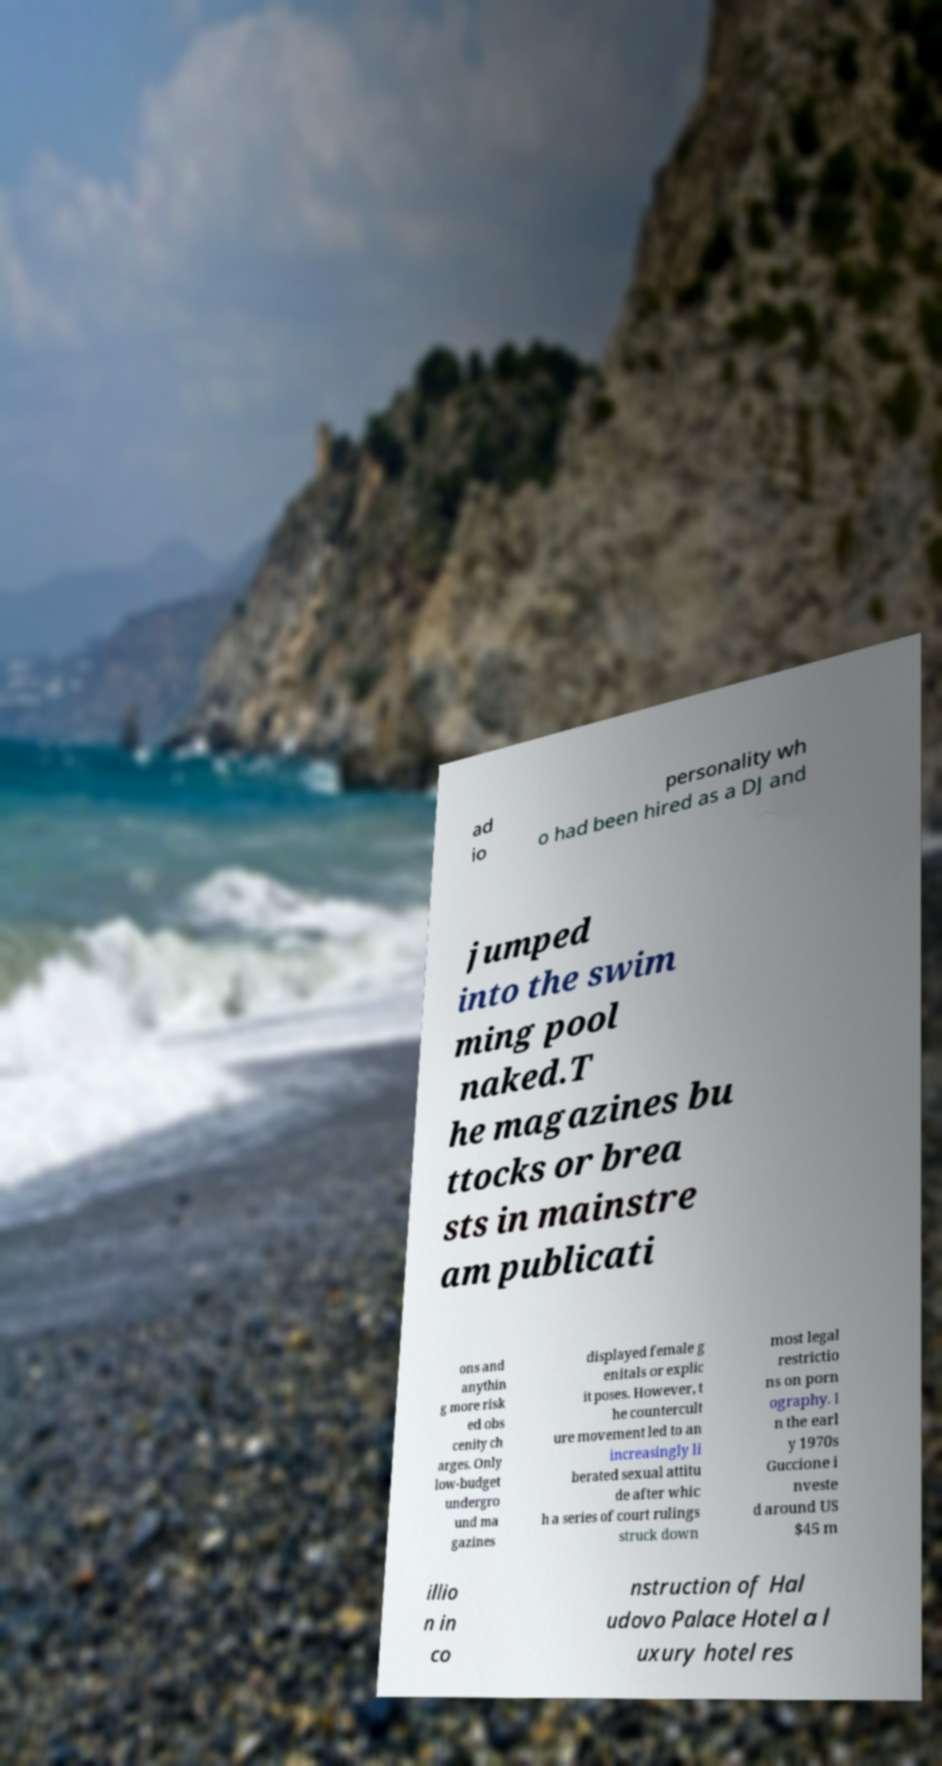Could you extract and type out the text from this image? ad io personality wh o had been hired as a DJ and jumped into the swim ming pool naked.T he magazines bu ttocks or brea sts in mainstre am publicati ons and anythin g more risk ed obs cenity ch arges. Only low-budget undergro und ma gazines displayed female g enitals or explic it poses. However, t he countercult ure movement led to an increasingly li berated sexual attitu de after whic h a series of court rulings struck down most legal restrictio ns on porn ography. I n the earl y 1970s Guccione i nveste d around US $45 m illio n in co nstruction of Hal udovo Palace Hotel a l uxury hotel res 